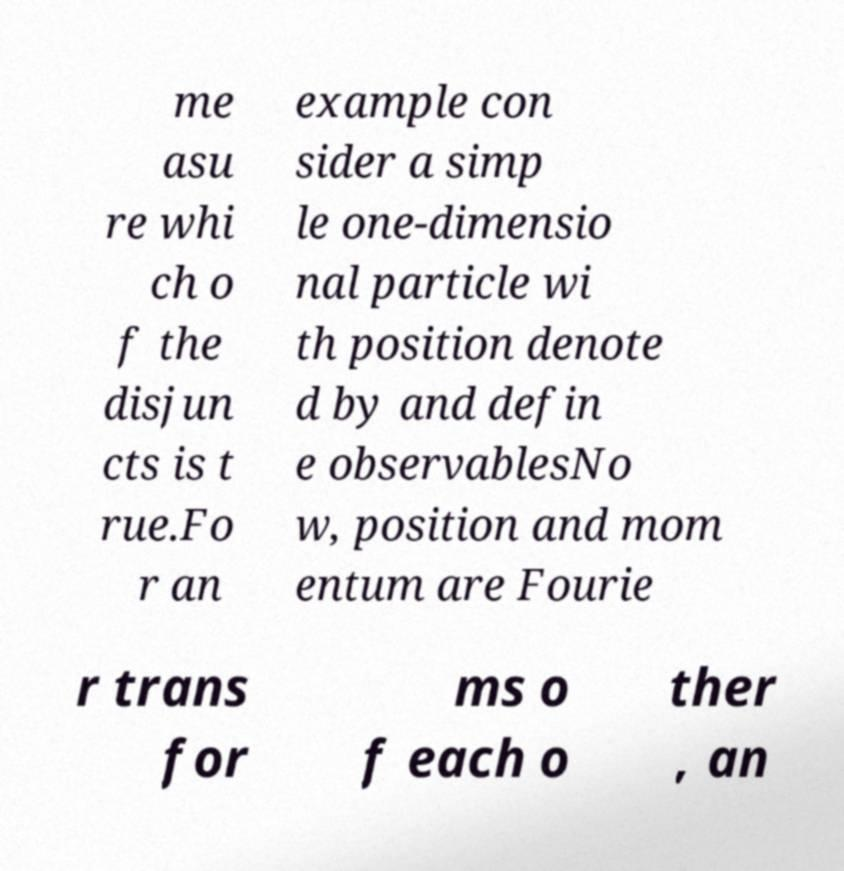Could you extract and type out the text from this image? me asu re whi ch o f the disjun cts is t rue.Fo r an example con sider a simp le one-dimensio nal particle wi th position denote d by and defin e observablesNo w, position and mom entum are Fourie r trans for ms o f each o ther , an 